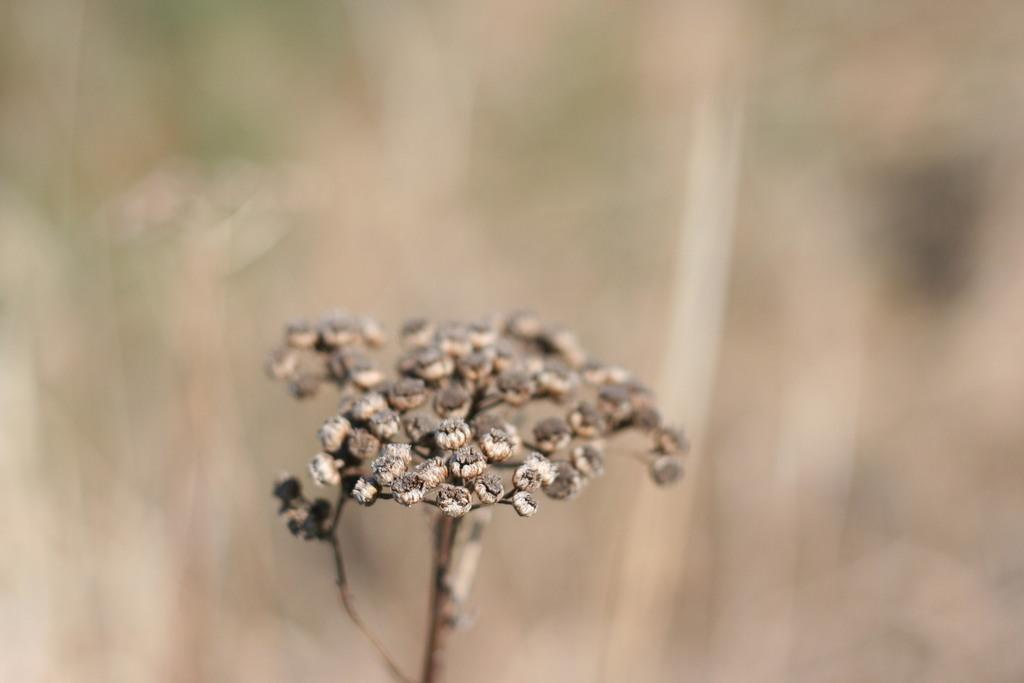What is present in the image? There is a plant in the image. Can you describe the background of the image? The background of the image is blurred. What type of expansion is taking place in the image? There is no expansion present in the image; it features a plant and a blurred background. How many times does the plant twist in the image? The plant does not twist in the image; it is stationary. 